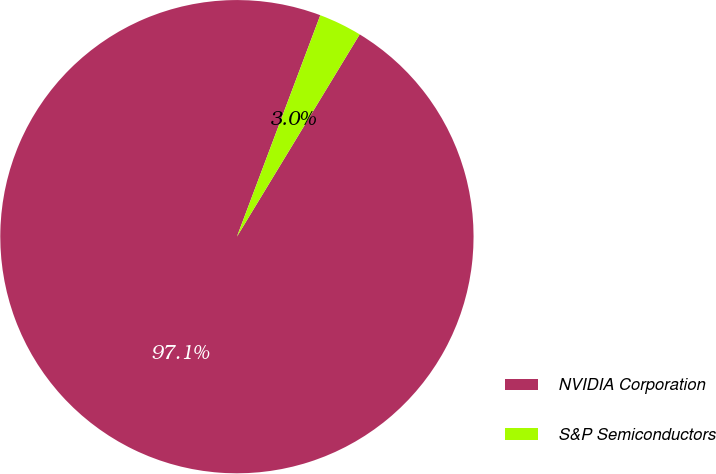<chart> <loc_0><loc_0><loc_500><loc_500><pie_chart><fcel>NVIDIA Corporation<fcel>S&P Semiconductors<nl><fcel>97.05%<fcel>2.95%<nl></chart> 